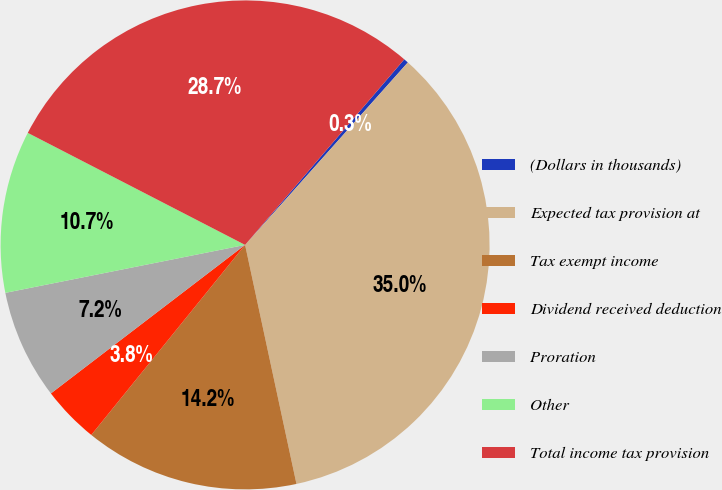<chart> <loc_0><loc_0><loc_500><loc_500><pie_chart><fcel>(Dollars in thousands)<fcel>Expected tax provision at<fcel>Tax exempt income<fcel>Dividend received deduction<fcel>Proration<fcel>Other<fcel>Total income tax provision<nl><fcel>0.31%<fcel>35.04%<fcel>14.2%<fcel>3.78%<fcel>7.25%<fcel>10.72%<fcel>28.71%<nl></chart> 